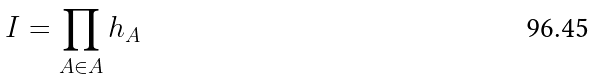Convert formula to latex. <formula><loc_0><loc_0><loc_500><loc_500>I = \prod _ { A \in A } h _ { A }</formula> 